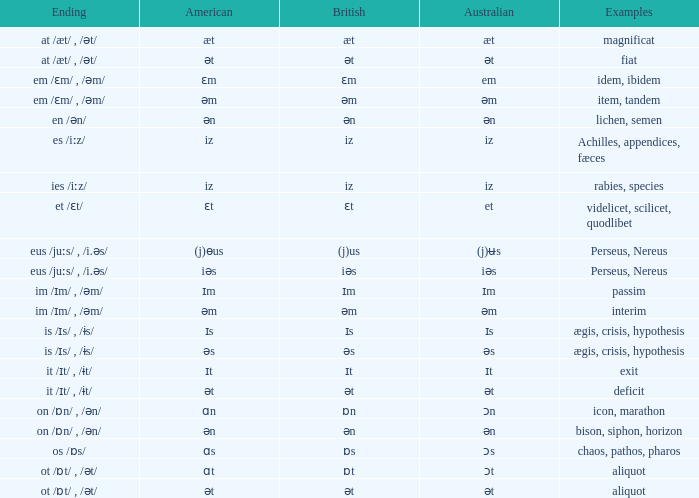Which British has Examples of exit? Ɪt. I'm looking to parse the entire table for insights. Could you assist me with that? {'header': ['Ending', 'American', 'British', 'Australian', 'Examples'], 'rows': [['at /æt/ , /ət/', 'æt', 'æt', 'æt', 'magnificat'], ['at /æt/ , /ət/', 'ət', 'ət', 'ət', 'fiat'], ['em /ɛm/ , /əm/', 'ɛm', 'ɛm', 'em', 'idem, ibidem'], ['em /ɛm/ , /əm/', 'əm', 'əm', 'əm', 'item, tandem'], ['en /ən/', 'ən', 'ən', 'ən', 'lichen, semen'], ['es /iːz/', 'iz', 'iz', 'iz', 'Achilles, appendices, fæces'], ['ies /iːz/', 'iz', 'iz', 'iz', 'rabies, species'], ['et /ɛt/', 'ɛt', 'ɛt', 'et', 'videlicet, scilicet, quodlibet'], ['eus /juːs/ , /i.əs/', '(j)ɵus', '(j)us', '(j)ʉs', 'Perseus, Nereus'], ['eus /juːs/ , /i.əs/', 'iəs', 'iəs', 'iəs', 'Perseus, Nereus'], ['im /ɪm/ , /əm/', 'ɪm', 'ɪm', 'ɪm', 'passim'], ['im /ɪm/ , /əm/', 'əm', 'əm', 'əm', 'interim'], ['is /ɪs/ , /ɨs/', 'ɪs', 'ɪs', 'ɪs', 'ægis, crisis, hypothesis'], ['is /ɪs/ , /ɨs/', 'əs', 'əs', 'əs', 'ægis, crisis, hypothesis'], ['it /ɪt/ , /ɨt/', 'ɪt', 'ɪt', 'ɪt', 'exit'], ['it /ɪt/ , /ɨt/', 'ət', 'ət', 'ət', 'deficit'], ['on /ɒn/ , /ən/', 'ɑn', 'ɒn', 'ɔn', 'icon, marathon'], ['on /ɒn/ , /ən/', 'ən', 'ən', 'ən', 'bison, siphon, horizon'], ['os /ɒs/', 'ɑs', 'ɒs', 'ɔs', 'chaos, pathos, pharos'], ['ot /ɒt/ , /ət/', 'ɑt', 'ɒt', 'ɔt', 'aliquot'], ['ot /ɒt/ , /ət/', 'ət', 'ət', 'ət', 'aliquot']]} 